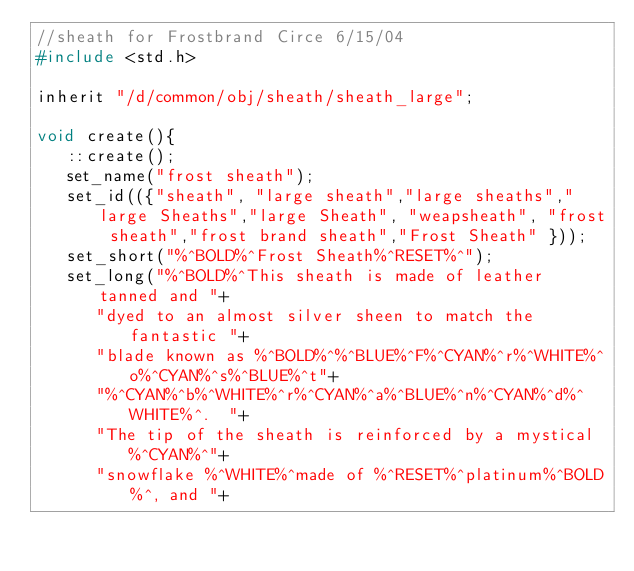<code> <loc_0><loc_0><loc_500><loc_500><_C_>//sheath for Frostbrand Circe 6/15/04
#include <std.h>

inherit "/d/common/obj/sheath/sheath_large";

void create(){
   ::create();
   set_name("frost sheath");
   set_id(({"sheath", "large sheath","large sheaths","large Sheaths","large Sheath", "weapsheath", "frost sheath","frost brand sheath","Frost Sheath" }));
   set_short("%^BOLD%^Frost Sheath%^RESET%^");
   set_long("%^BOLD%^This sheath is made of leather tanned and "+
      "dyed to an almost silver sheen to match the fantastic "+
      "blade known as %^BOLD%^%^BLUE%^F%^CYAN%^r%^WHITE%^o%^CYAN%^s%^BLUE%^t"+
      "%^CYAN%^b%^WHITE%^r%^CYAN%^a%^BLUE%^n%^CYAN%^d%^WHITE%^.  "+
      "The tip of the sheath is reinforced by a mystical %^CYAN%^"+
      "snowflake %^WHITE%^made of %^RESET%^platinum%^BOLD%^, and "+</code> 